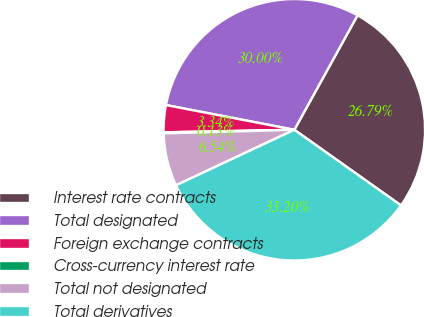Convert chart. <chart><loc_0><loc_0><loc_500><loc_500><pie_chart><fcel>Interest rate contracts<fcel>Total designated<fcel>Foreign exchange contracts<fcel>Cross-currency interest rate<fcel>Total not designated<fcel>Total derivatives<nl><fcel>26.79%<fcel>30.0%<fcel>3.34%<fcel>0.13%<fcel>6.54%<fcel>33.2%<nl></chart> 